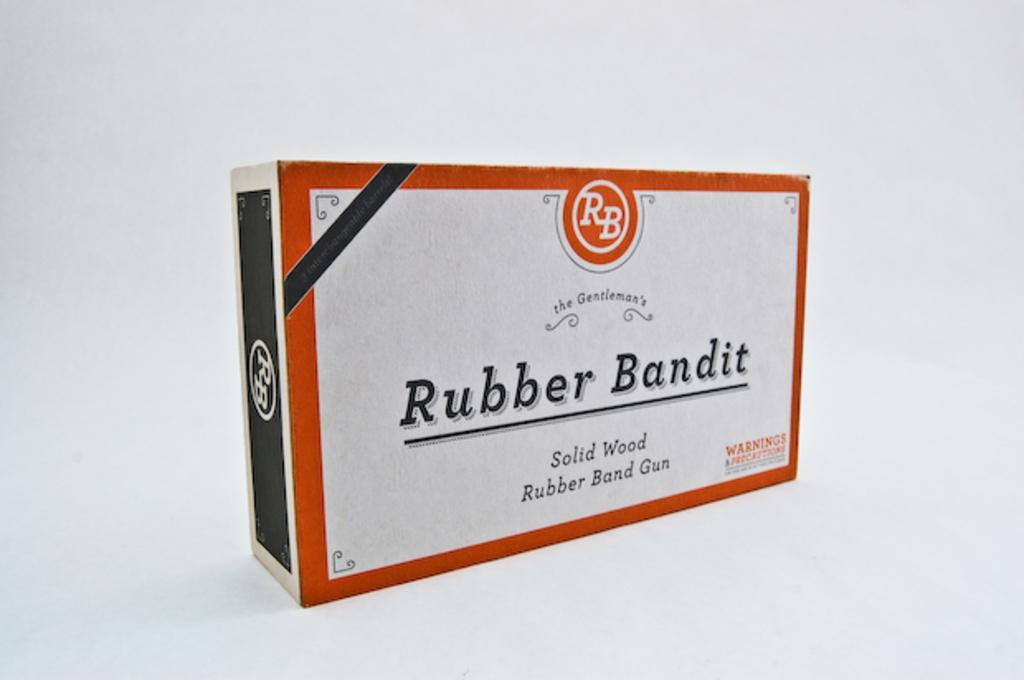<image>
Present a compact description of the photo's key features. A box for a Rubber Bandit Rubber Band Gun. 